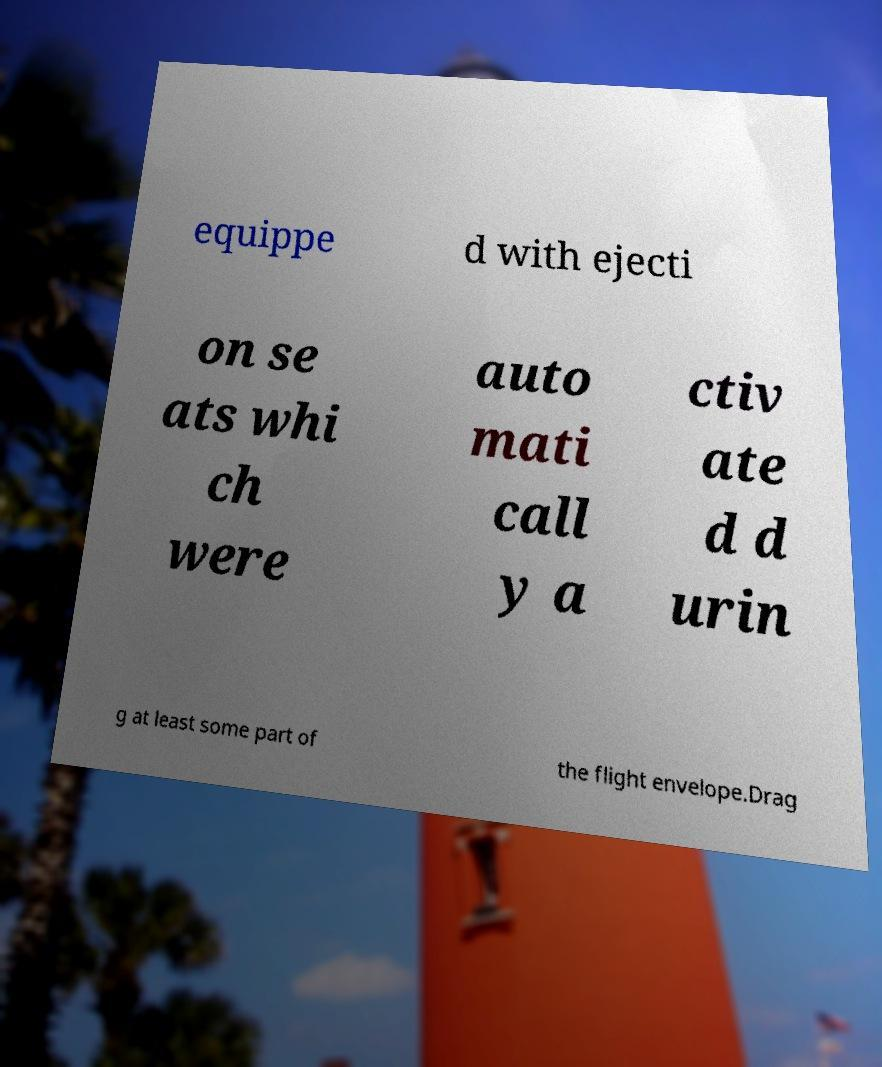Could you assist in decoding the text presented in this image and type it out clearly? equippe d with ejecti on se ats whi ch were auto mati call y a ctiv ate d d urin g at least some part of the flight envelope.Drag 